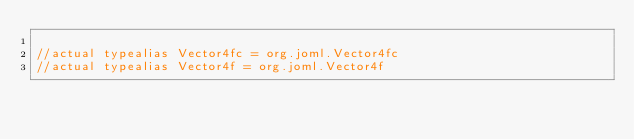<code> <loc_0><loc_0><loc_500><loc_500><_Kotlin_>
//actual typealias Vector4fc = org.joml.Vector4fc
//actual typealias Vector4f = org.joml.Vector4f</code> 